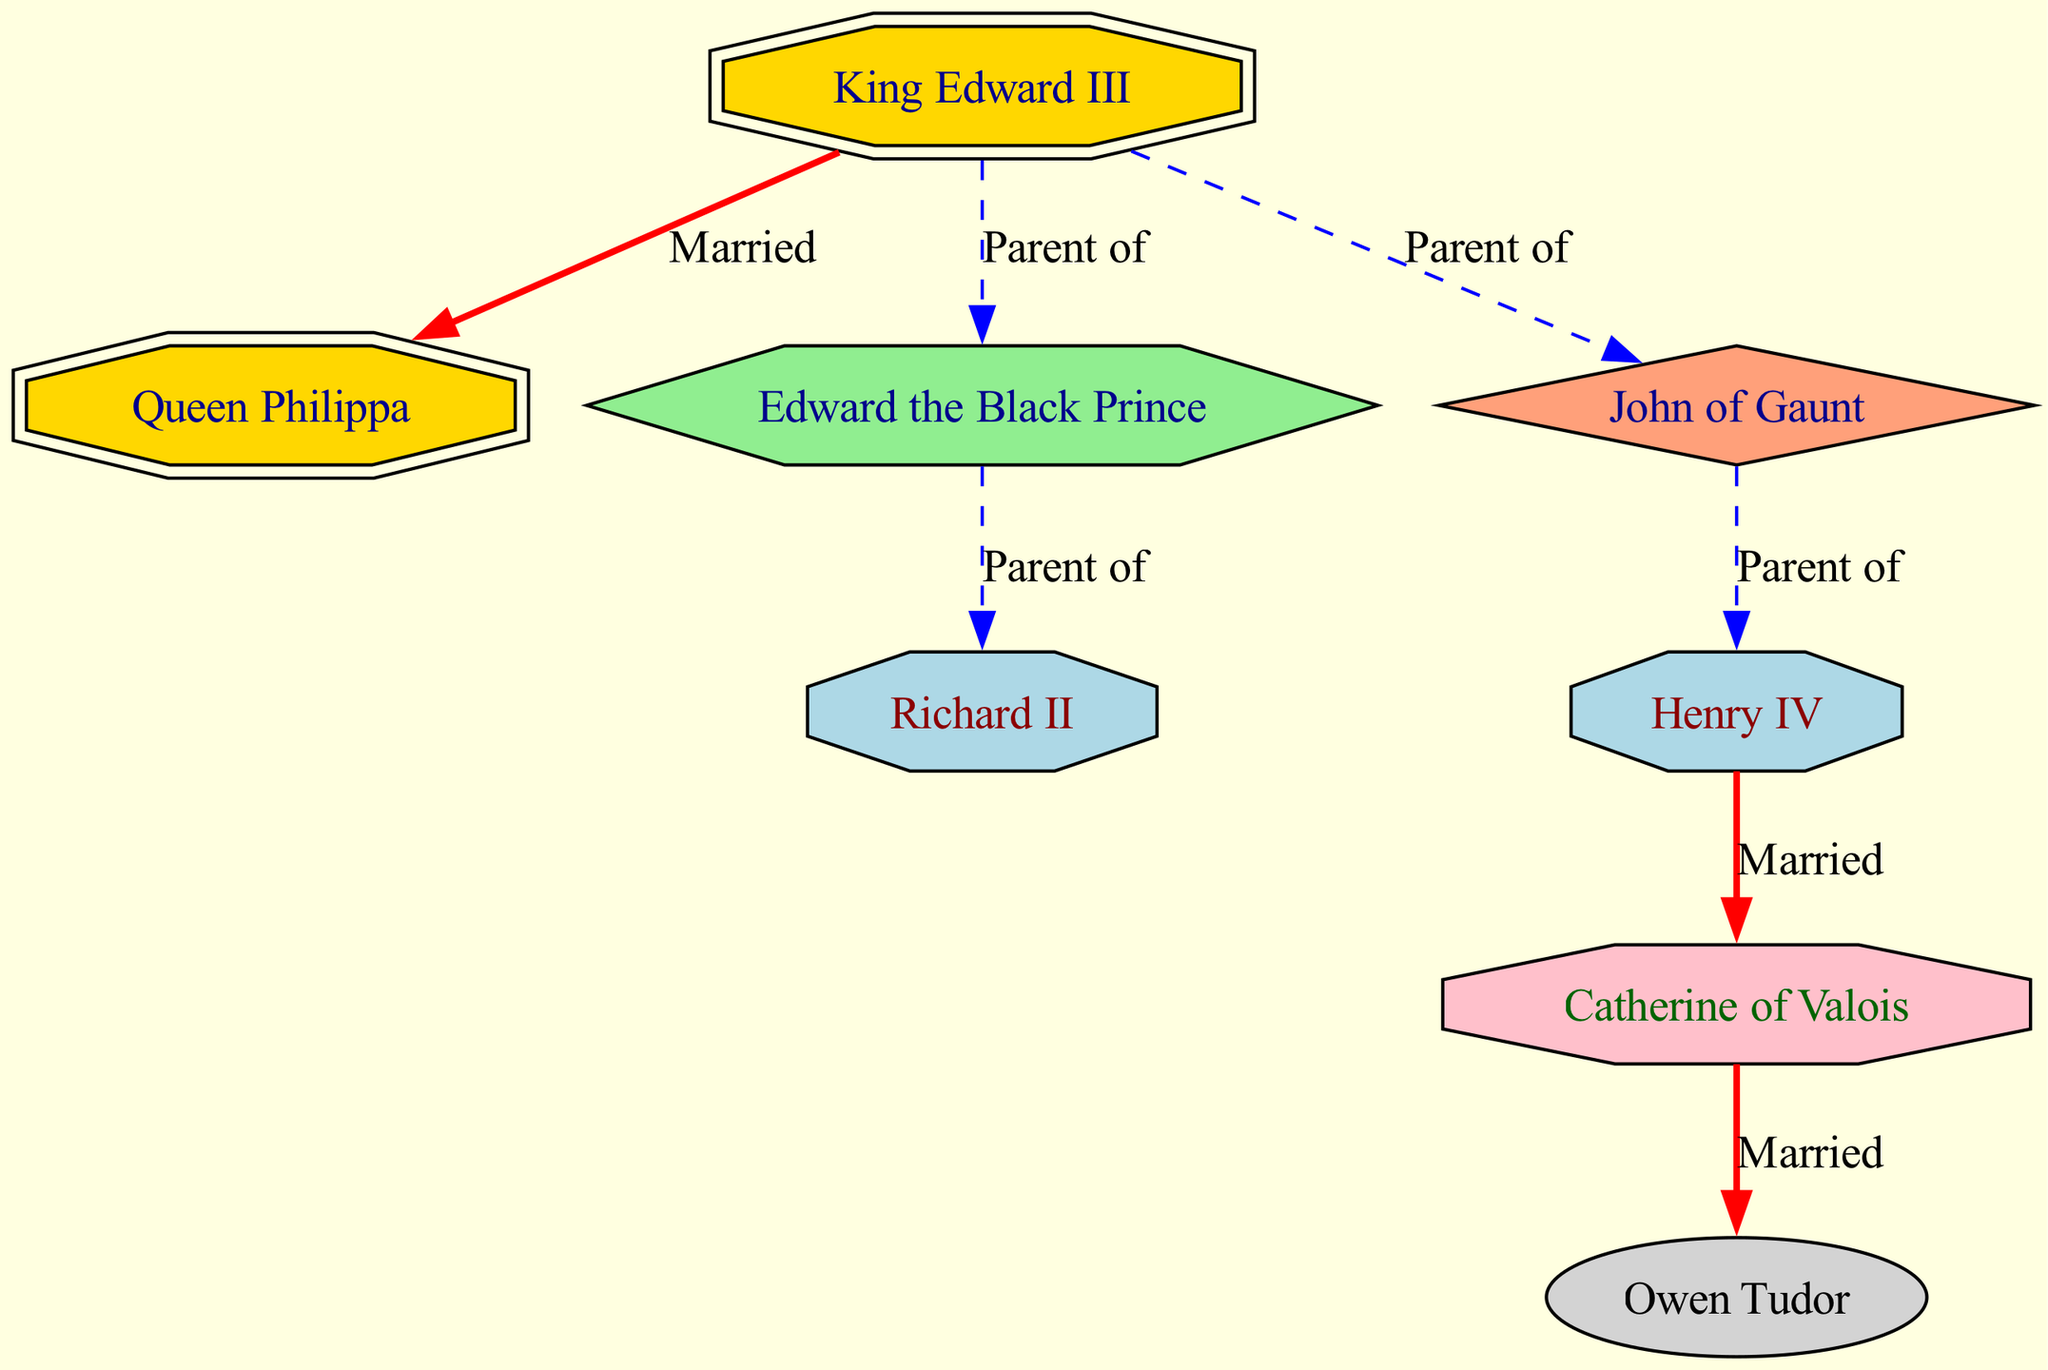What is the relationship between King Edward III and Queen Philippa? The diagram shows a direct edge between King Edward III and Queen Philippa labeled "Married." This indicates that King Edward III is married to Queen Philippa.
Answer: Married How many nodes are there in the diagram? By counting the entries in the 'nodes' section of the data, we find there are a total of 8 nodes representing various characters.
Answer: 8 Who is the parent of Edward II? The diagram indicates that Edward the Black Prince (id: 3) has a direct edge labeled "Parent of" connecting to Richard II (id: 5), meaning Edward the Black Prince is the father of Richard II.
Answer: Edward the Black Prince How many edges connect John of Gaunt? The edges show that John of Gaunt (id: 4) has one outgoing edge to Henry IV (id: 6), indicating he is the parent of Henry IV. Thus, there is 1 edge.
Answer: 1 What type of character is Catherine of Valois? The diagram categorizes her as 'Queen,' which is indicated by the type label next to her name.
Answer: Queen Which two characters are married according to the diagram? The diagram has an edge between Henry IV (id: 6) and Catherine of Valois (id: 7) labeled "Married." Furthermore, it connects Owen Tudor (id: 8) with Catherine of Valois (id: 7) also labeled "Married."
Answer: Henry IV and Catherine of Valois; Catherine of Valois and Owen Tudor Who has the most parental connections? By analyzing the diagram, King Edward III (id: 1) has two outgoing edges labeled "Parent of," connecting him to both Edward the Black Prince (id: 3) and John of Gaunt (id: 4). Therefore, he has the most parental connections in this context.
Answer: King Edward III How many monarchs are present in the diagram? The diagram shows three distinct nodes categorized as Monarch: King Edward III (id: 1), Queen Philippa (id: 2), and Richard II (id: 5). Therefore, there are three monarchs present.
Answer: 3 Which character is the child of John of Gaunt? The diagram shows John of Gaunt (id: 4) with a "Parent of" edge connection to Henry IV (id: 6), indicating that Henry IV is the child of John of Gaunt.
Answer: Henry IV 